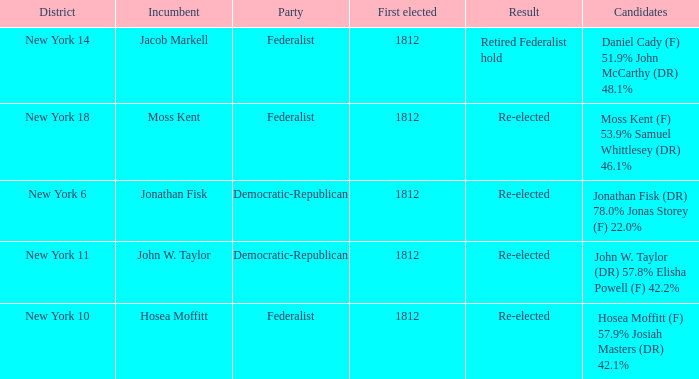Name the first elected for hosea moffitt (f) 57.9% josiah masters (dr) 42.1% 1812.0. 